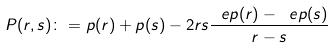<formula> <loc_0><loc_0><loc_500><loc_500>P ( r , s ) \colon = p ( r ) + p ( s ) - 2 r s \frac { \ e p ( r ) - \ e p ( s ) } { r - s }</formula> 